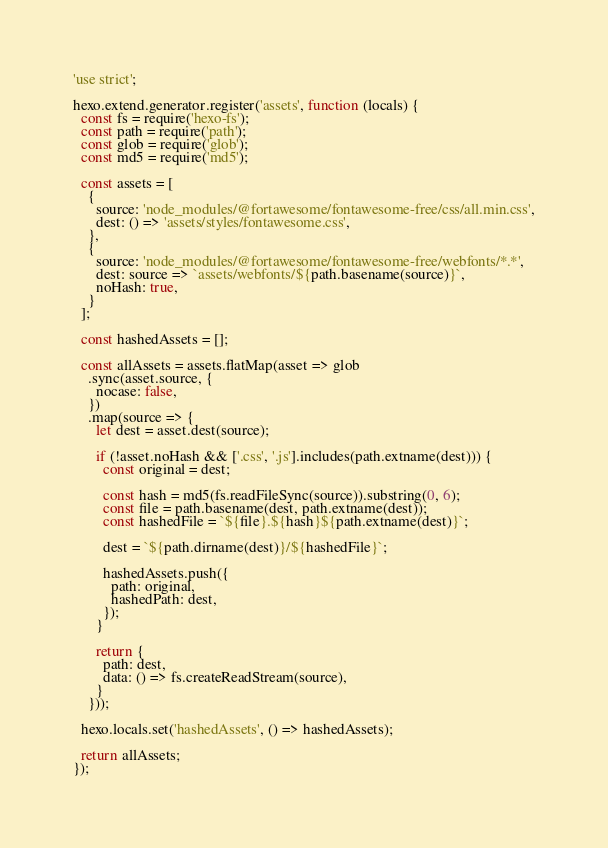Convert code to text. <code><loc_0><loc_0><loc_500><loc_500><_JavaScript_>'use strict';

hexo.extend.generator.register('assets', function (locals) {
  const fs = require('hexo-fs');
  const path = require('path');
  const glob = require('glob');
  const md5 = require('md5');

  const assets = [
    {
      source: 'node_modules/@fortawesome/fontawesome-free/css/all.min.css',
      dest: () => 'assets/styles/fontawesome.css',
    },
    {
      source: 'node_modules/@fortawesome/fontawesome-free/webfonts/*.*',
      dest: source => `assets/webfonts/${path.basename(source)}`,
      noHash: true,
    }
  ];

  const hashedAssets = [];

  const allAssets = assets.flatMap(asset => glob
    .sync(asset.source, {
      nocase: false,
    })
    .map(source => {
      let dest = asset.dest(source);

      if (!asset.noHash && ['.css', '.js'].includes(path.extname(dest))) {
        const original = dest;

        const hash = md5(fs.readFileSync(source)).substring(0, 6);
        const file = path.basename(dest, path.extname(dest));
        const hashedFile = `${file}.${hash}${path.extname(dest)}`;

        dest = `${path.dirname(dest)}/${hashedFile}`;

        hashedAssets.push({
          path: original,
          hashedPath: dest,
        });
      }

      return {
        path: dest,
        data: () => fs.createReadStream(source),
      }
    }));

  hexo.locals.set('hashedAssets', () => hashedAssets);

  return allAssets;
});
</code> 